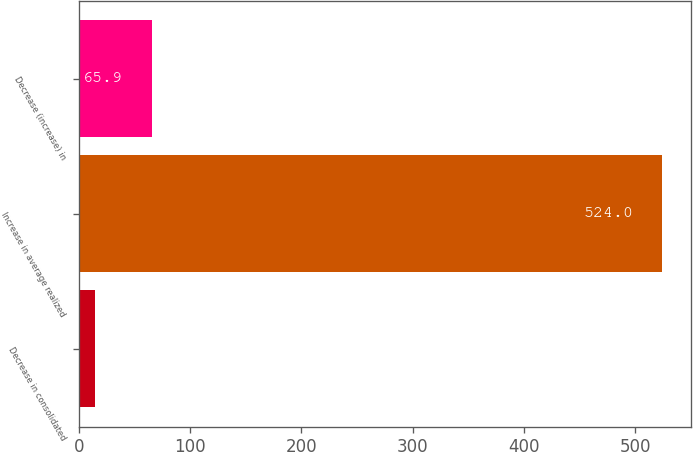Convert chart. <chart><loc_0><loc_0><loc_500><loc_500><bar_chart><fcel>Decrease in consolidated<fcel>Increase in average realized<fcel>Decrease (increase) in<nl><fcel>15<fcel>524<fcel>65.9<nl></chart> 